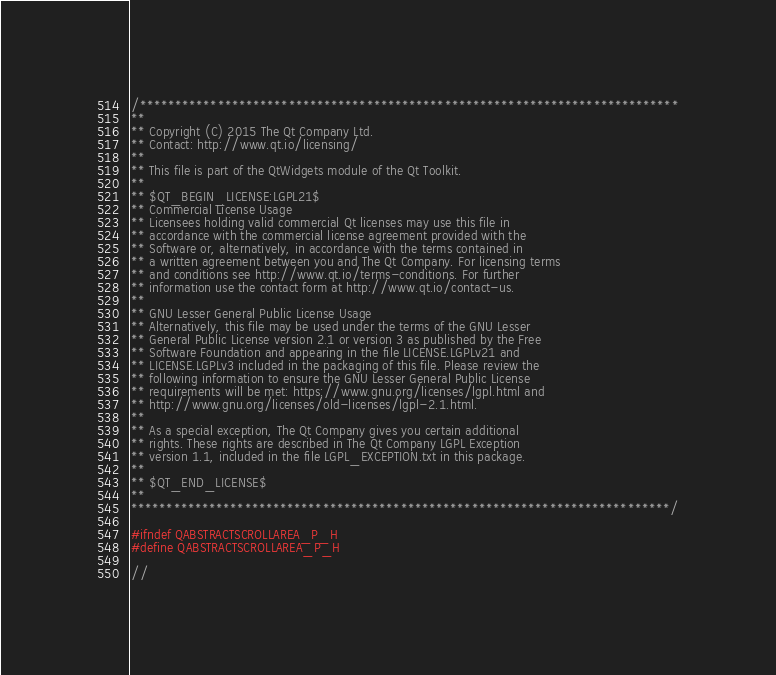Convert code to text. <code><loc_0><loc_0><loc_500><loc_500><_C_>/****************************************************************************
**
** Copyright (C) 2015 The Qt Company Ltd.
** Contact: http://www.qt.io/licensing/
**
** This file is part of the QtWidgets module of the Qt Toolkit.
**
** $QT_BEGIN_LICENSE:LGPL21$
** Commercial License Usage
** Licensees holding valid commercial Qt licenses may use this file in
** accordance with the commercial license agreement provided with the
** Software or, alternatively, in accordance with the terms contained in
** a written agreement between you and The Qt Company. For licensing terms
** and conditions see http://www.qt.io/terms-conditions. For further
** information use the contact form at http://www.qt.io/contact-us.
**
** GNU Lesser General Public License Usage
** Alternatively, this file may be used under the terms of the GNU Lesser
** General Public License version 2.1 or version 3 as published by the Free
** Software Foundation and appearing in the file LICENSE.LGPLv21 and
** LICENSE.LGPLv3 included in the packaging of this file. Please review the
** following information to ensure the GNU Lesser General Public License
** requirements will be met: https://www.gnu.org/licenses/lgpl.html and
** http://www.gnu.org/licenses/old-licenses/lgpl-2.1.html.
**
** As a special exception, The Qt Company gives you certain additional
** rights. These rights are described in The Qt Company LGPL Exception
** version 1.1, included in the file LGPL_EXCEPTION.txt in this package.
**
** $QT_END_LICENSE$
**
****************************************************************************/

#ifndef QABSTRACTSCROLLAREA_P_H
#define QABSTRACTSCROLLAREA_P_H

//</code> 